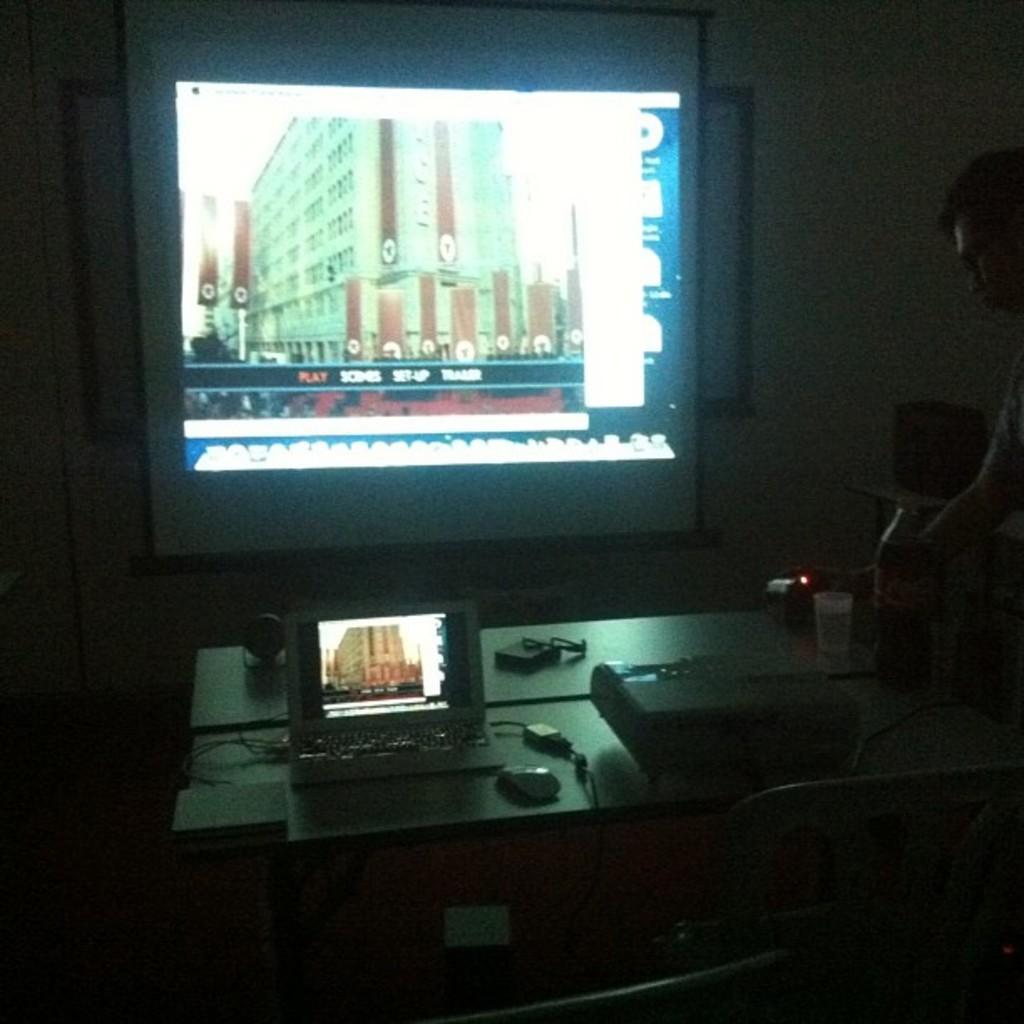How would you summarize this image in a sentence or two? In this image there is a person truncated towards the right of the image, there is a table, there are objects on the table, there is a laptop, there is a projector, there is a screen, there is the wall, there is a building, there is text on the screen, there is a photo frame on the wall, there are chairs truncated towards the bottom of the image. 